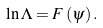Convert formula to latex. <formula><loc_0><loc_0><loc_500><loc_500>\ln \Lambda = F \left ( \psi \right ) .</formula> 